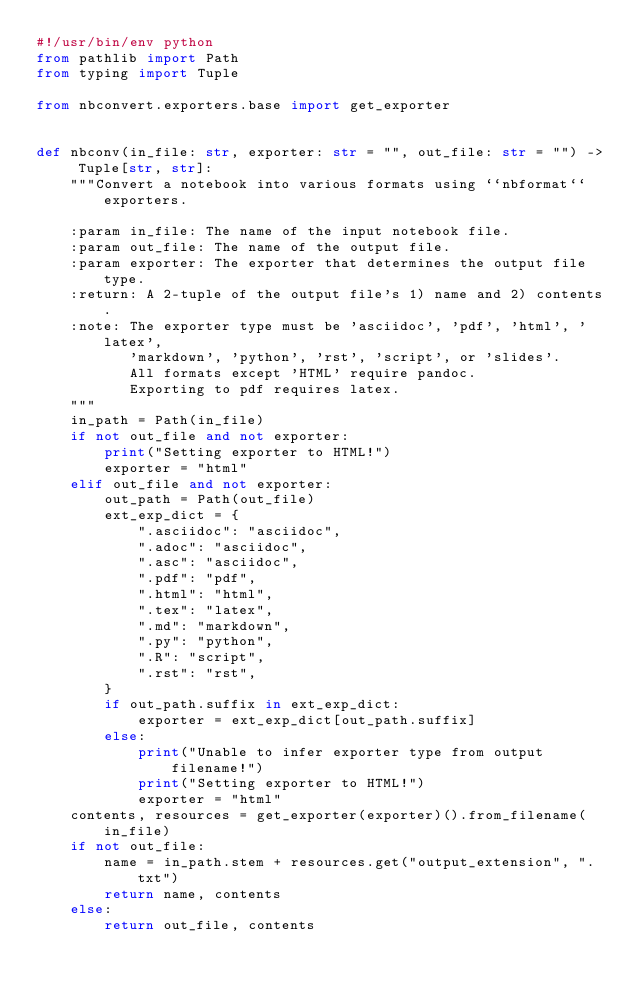Convert code to text. <code><loc_0><loc_0><loc_500><loc_500><_Python_>#!/usr/bin/env python
from pathlib import Path
from typing import Tuple

from nbconvert.exporters.base import get_exporter


def nbconv(in_file: str, exporter: str = "", out_file: str = "") -> Tuple[str, str]:
    """Convert a notebook into various formats using ``nbformat`` exporters.

    :param in_file: The name of the input notebook file.
    :param out_file: The name of the output file.
    :param exporter: The exporter that determines the output file type.
    :return: A 2-tuple of the output file's 1) name and 2) contents.
    :note: The exporter type must be 'asciidoc', 'pdf', 'html', 'latex',
           'markdown', 'python', 'rst', 'script', or 'slides'.
           All formats except 'HTML' require pandoc.
           Exporting to pdf requires latex.
    """
    in_path = Path(in_file)
    if not out_file and not exporter:
        print("Setting exporter to HTML!")
        exporter = "html"
    elif out_file and not exporter:
        out_path = Path(out_file)
        ext_exp_dict = {
            ".asciidoc": "asciidoc",
            ".adoc": "asciidoc",
            ".asc": "asciidoc",
            ".pdf": "pdf",
            ".html": "html",
            ".tex": "latex",
            ".md": "markdown",
            ".py": "python",
            ".R": "script",
            ".rst": "rst",
        }
        if out_path.suffix in ext_exp_dict:
            exporter = ext_exp_dict[out_path.suffix]
        else:
            print("Unable to infer exporter type from output filename!")
            print("Setting exporter to HTML!")
            exporter = "html"
    contents, resources = get_exporter(exporter)().from_filename(in_file)
    if not out_file:
        name = in_path.stem + resources.get("output_extension", ".txt")
        return name, contents
    else:
        return out_file, contents
</code> 